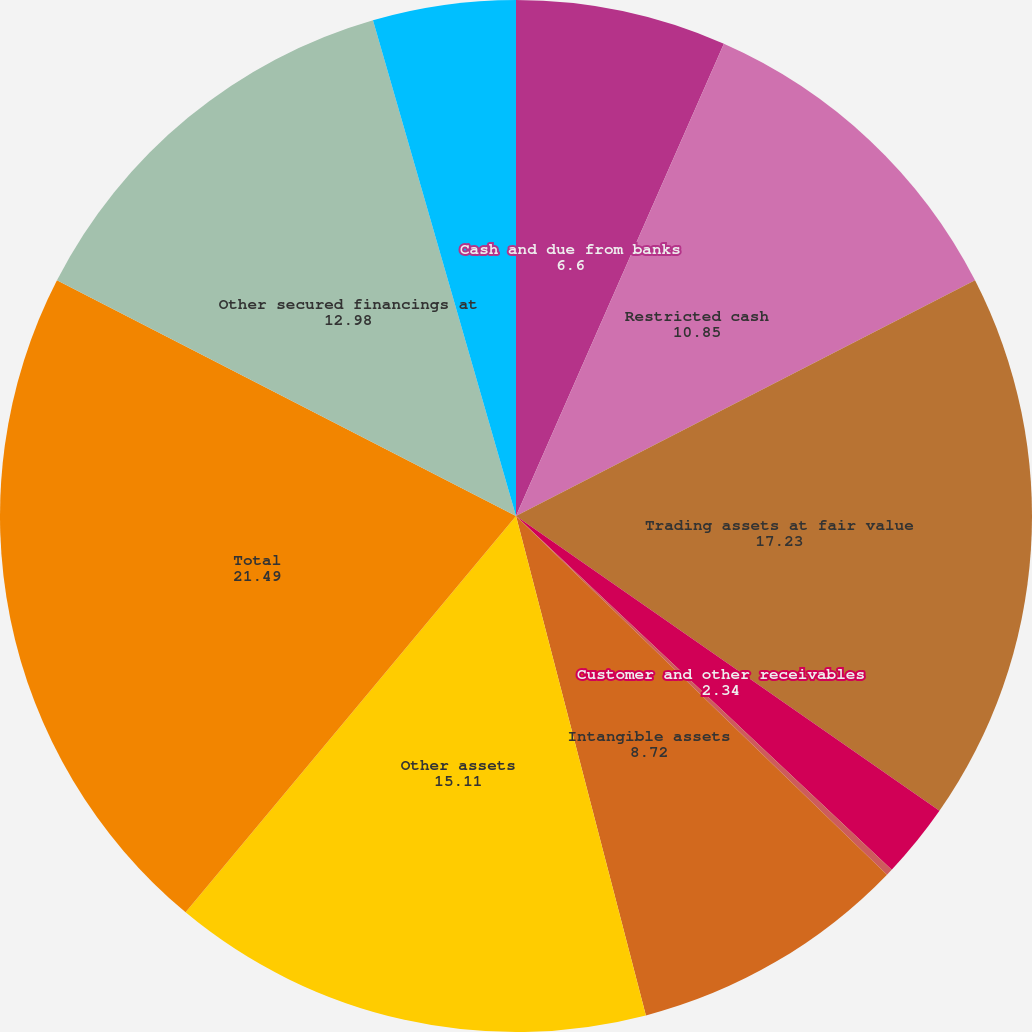Convert chart to OTSL. <chart><loc_0><loc_0><loc_500><loc_500><pie_chart><fcel>Cash and due from banks<fcel>Restricted cash<fcel>Trading assets at fair value<fcel>Customer and other receivables<fcel>Goodwill<fcel>Intangible assets<fcel>Other assets<fcel>Total<fcel>Other secured financings at<fcel>Other liabilities and accrued<nl><fcel>6.6%<fcel>10.85%<fcel>17.23%<fcel>2.34%<fcel>0.21%<fcel>8.72%<fcel>15.11%<fcel>21.49%<fcel>12.98%<fcel>4.47%<nl></chart> 